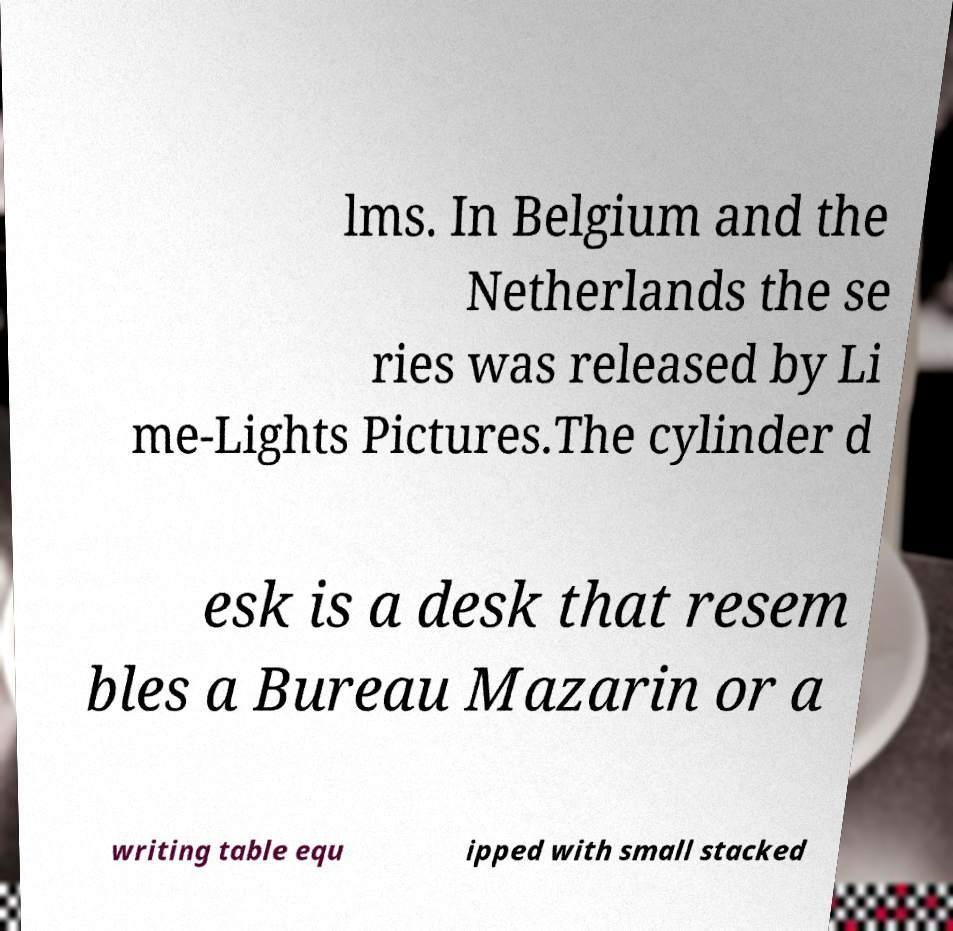What messages or text are displayed in this image? I need them in a readable, typed format. lms. In Belgium and the Netherlands the se ries was released by Li me-Lights Pictures.The cylinder d esk is a desk that resem bles a Bureau Mazarin or a writing table equ ipped with small stacked 